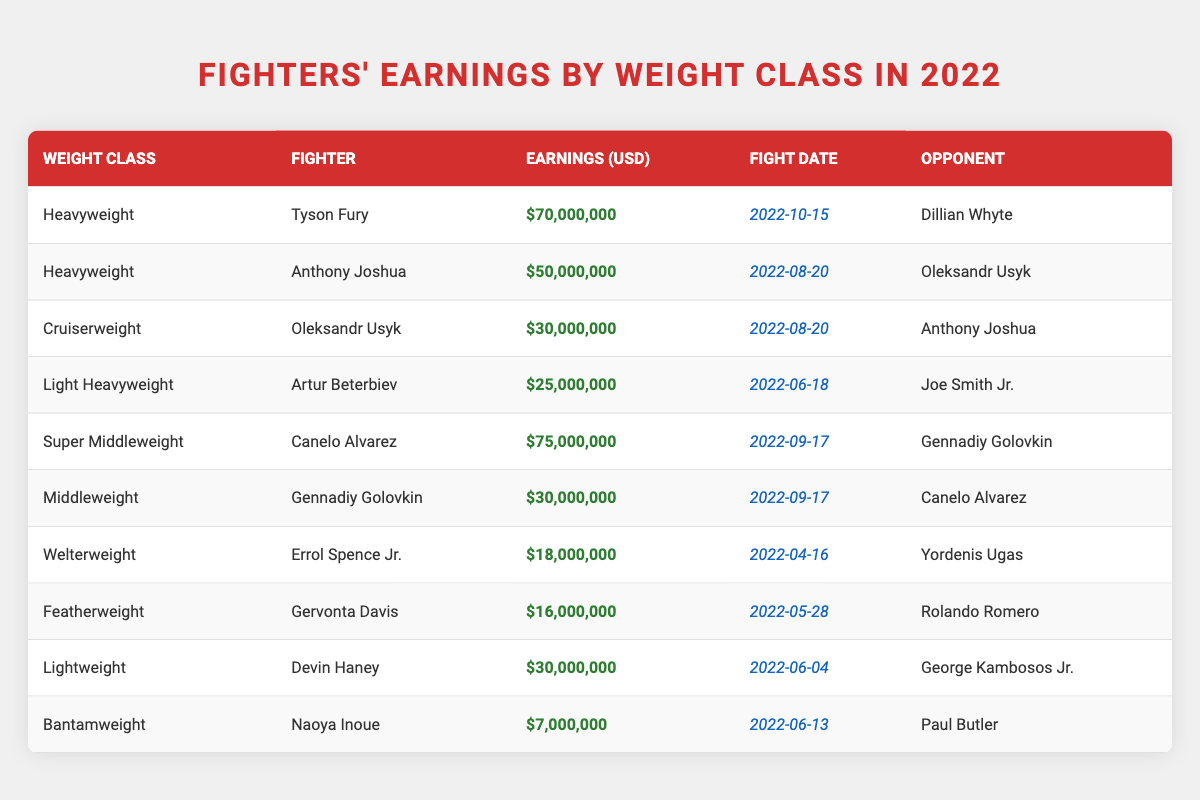What was the highest earning among the fighters listed? The table shows various fighters with their earnings. Scanning through the "Earnings (USD)" column, the highest value is for Canelo Alvarez at $75,000,000.
Answer: $75,000,000 Which fighter earned the least in 2022? Looking at the "Earnings (USD)" column, the lowest earning is for Naoya Inoue, who earned $7,000,000.
Answer: $7,000,000 How much did Tyson Fury earn more than Anthony Joshua? Comparing the earnings of Tyson Fury, which is $70,000,000, and Anthony Joshua, who earned $50,000,000, the difference is $70,000,000 - $50,000,000 = $20,000,000.
Answer: $20,000,000 What is the total earnings of all fighters in the Heavyweight class? The Heavyweight class has two fighters: Tyson Fury with $70,000,000 and Anthony Joshua with $50,000,000. Adding these together gives $70,000,000 + $50,000,000 = $120,000,000.
Answer: $120,000,000 Did Canelo Alvarez fight in the Cruiserweight division? Canelo Alvarez is listed under the Super Middleweight category, so he did not fight in the Cruiserweight division.
Answer: No What was the average earning of the fighters in the Lightweight and Middleweight categories? The Lightweight category has Devin Haney earning $30,000,000, and the Middleweight category has Gennadiy Golovkin earning $30,000,000. The average is calculated as ($30,000,000 + $30,000,000) / 2 = $30,000,000.
Answer: $30,000,000 Which fighter earned $30,000,000 and fought on June 4, 2022? The fighter who earned $30,000,000 and fought on June 4, 2022, is Devin Haney.
Answer: Devin Haney If we categorize the fighters by upper tier (earnings above $30 million) and lower tier (earnings below or equal to $30 million), how many fighters are in each category? The upper tier consists of Canelo Alvarez ($75 million), Tyson Fury ($70 million), Anthony Joshua ($50 million), Oleksandr Usyk ($30 million), while the lower tier includes Artur Beterbiev ($25 million), Gennadiy Golovkin ($30 million), Errol Spence Jr. ($18 million), Gervonta Davis ($16 million), and Naoya Inoue ($7 million). Upper tier has 4 fighters and lower tier has 5 fighters.
Answer: Upper tier: 4, Lower tier: 5 What percentage of the total earnings is attributed to the Super Middleweight class? The total earnings across all fighters is $70M + $50M + $30M + $25M + $75M + $30M + $18M + $16M + $30M + $7M = $351M. The Super Middleweight class (Canelo Alvarez) earned $75M. The percentage is ($75M / $351M) * 100 = approximately 21.4%.
Answer: 21.4% 